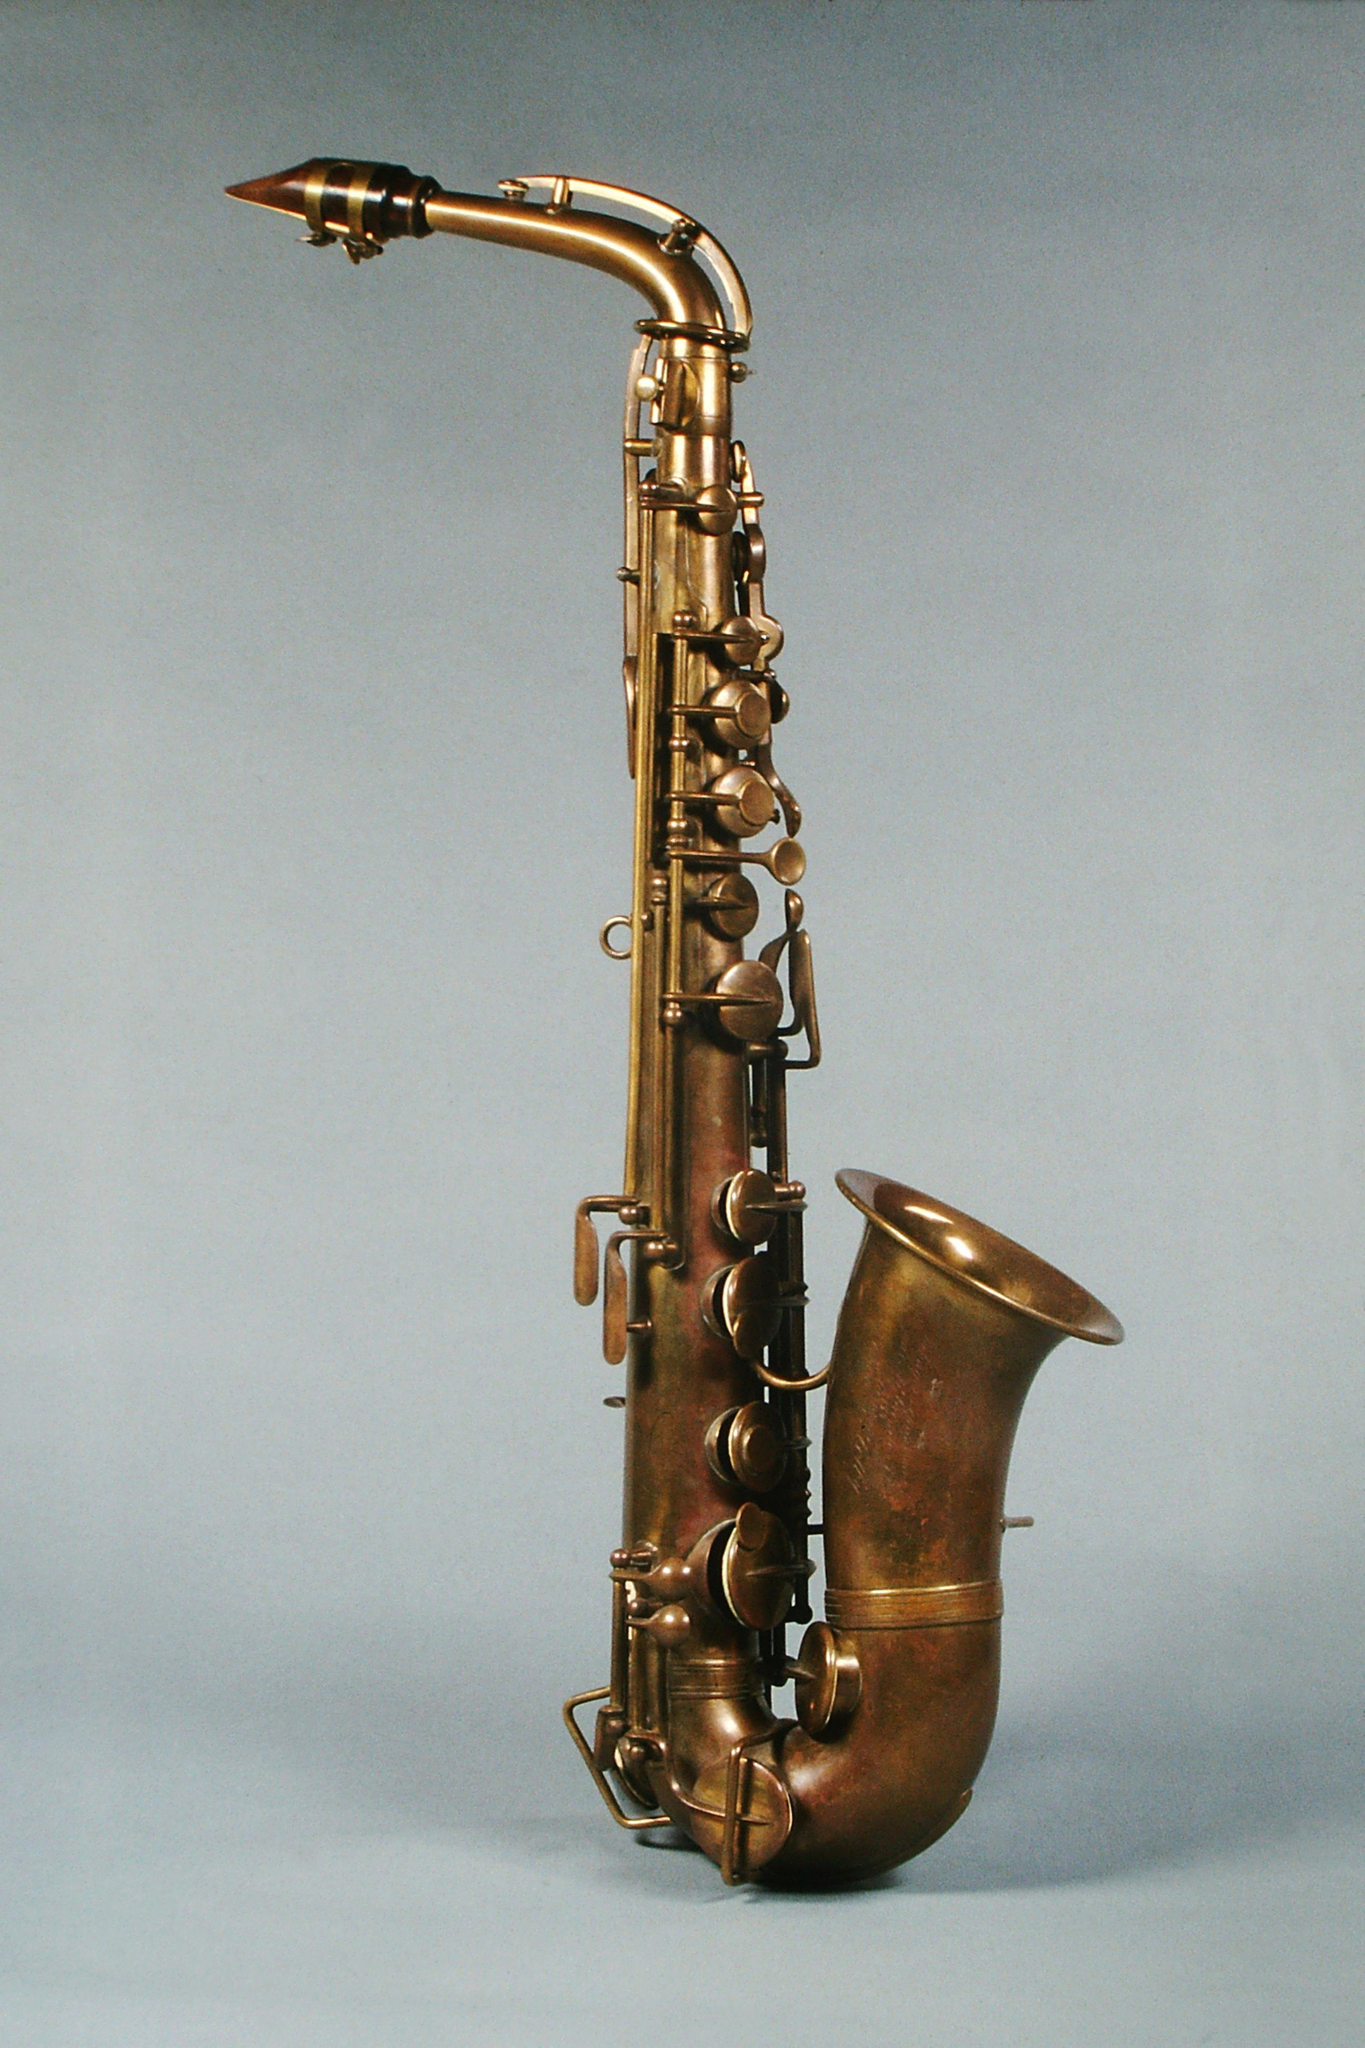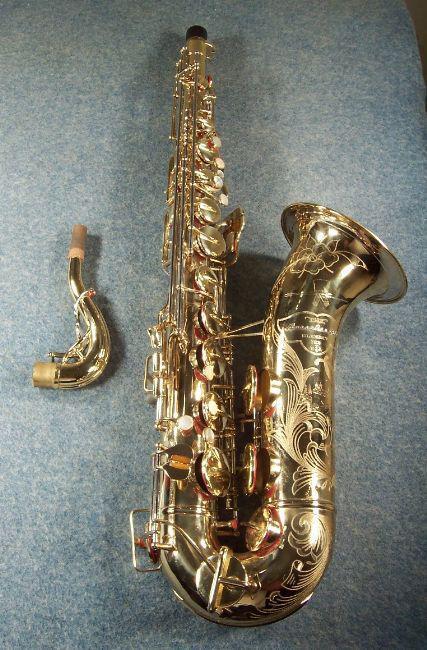The first image is the image on the left, the second image is the image on the right. Given the left and right images, does the statement "An image shows one saxophone that seems to be standing up on a flat ground, instead of lying flat or floating." hold true? Answer yes or no. Yes. 